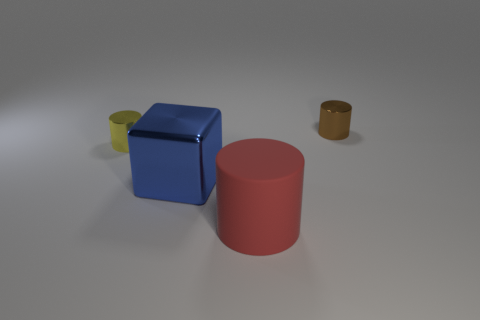Does the tiny cylinder that is on the right side of the big blue thing have the same material as the cylinder that is in front of the small yellow metal thing?
Offer a terse response. No. How many things are small shiny cylinders right of the red rubber thing or metallic things on the left side of the rubber cylinder?
Your response must be concise. 3. There is a shiny thing that is on the right side of the yellow cylinder and to the left of the small brown object; what is its shape?
Offer a terse response. Cube. There is a metallic cube that is the same size as the red matte cylinder; what is its color?
Offer a terse response. Blue. Does the shiny cylinder that is to the left of the small brown cylinder have the same size as the metal cylinder behind the yellow cylinder?
Provide a succinct answer. Yes. What is the thing that is both on the right side of the shiny cube and behind the blue thing made of?
Give a very brief answer. Metal. What is the small thing left of the brown cylinder made of?
Ensure brevity in your answer.  Metal. Is the brown metal object the same shape as the red thing?
Your response must be concise. Yes. What number of other objects are there of the same shape as the big blue metallic object?
Offer a terse response. 0. What is the color of the cylinder right of the big cylinder?
Ensure brevity in your answer.  Brown. 